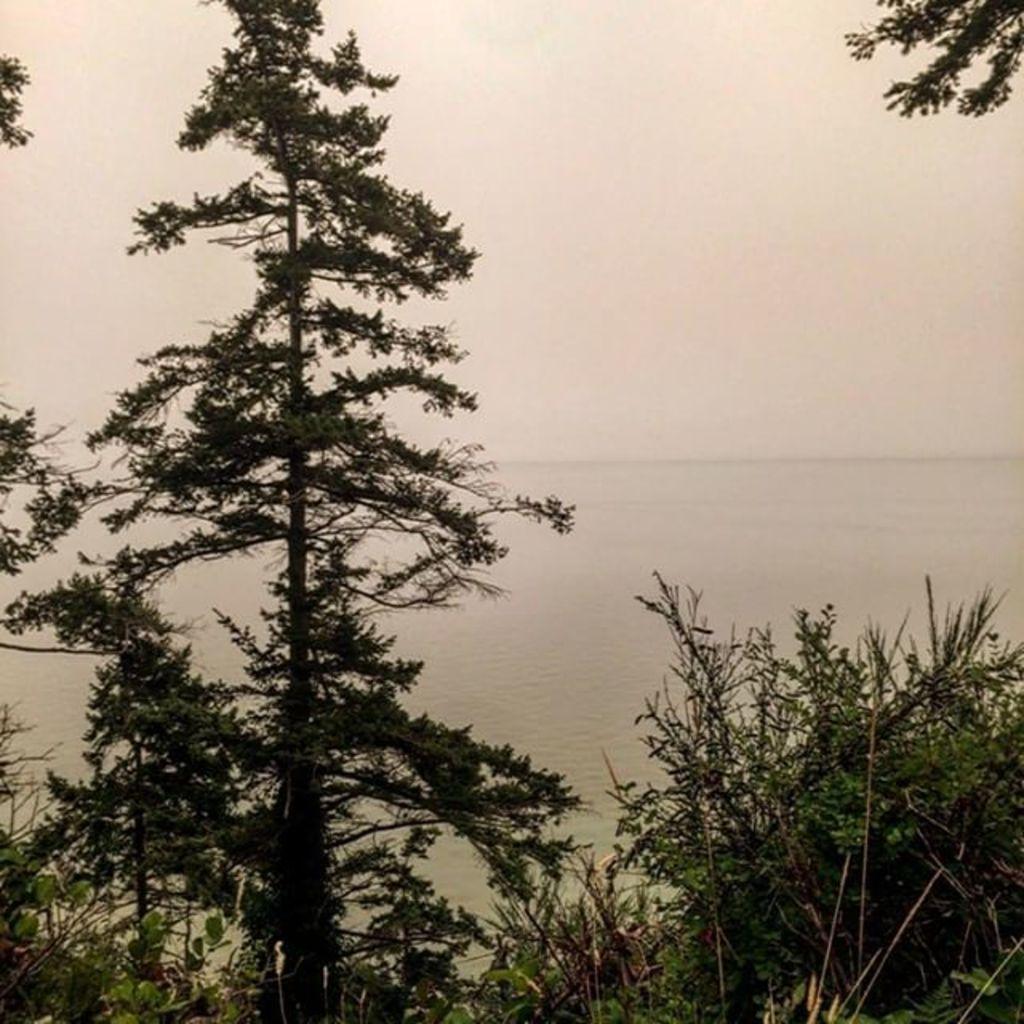Can you describe this image briefly? In this picture I can see trees. In the background I can see water and the sky. 